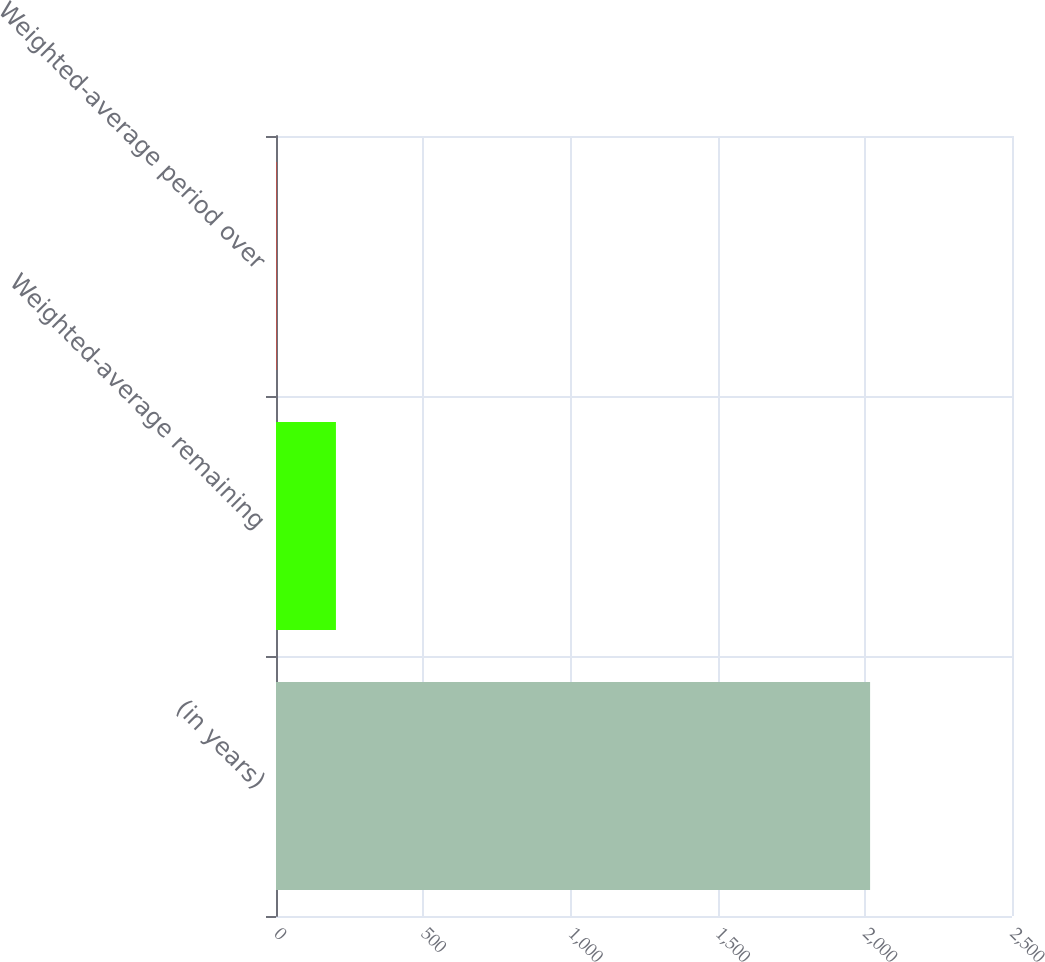<chart> <loc_0><loc_0><loc_500><loc_500><bar_chart><fcel>(in years)<fcel>Weighted-average remaining<fcel>Weighted-average period over<nl><fcel>2018<fcel>203.6<fcel>2<nl></chart> 